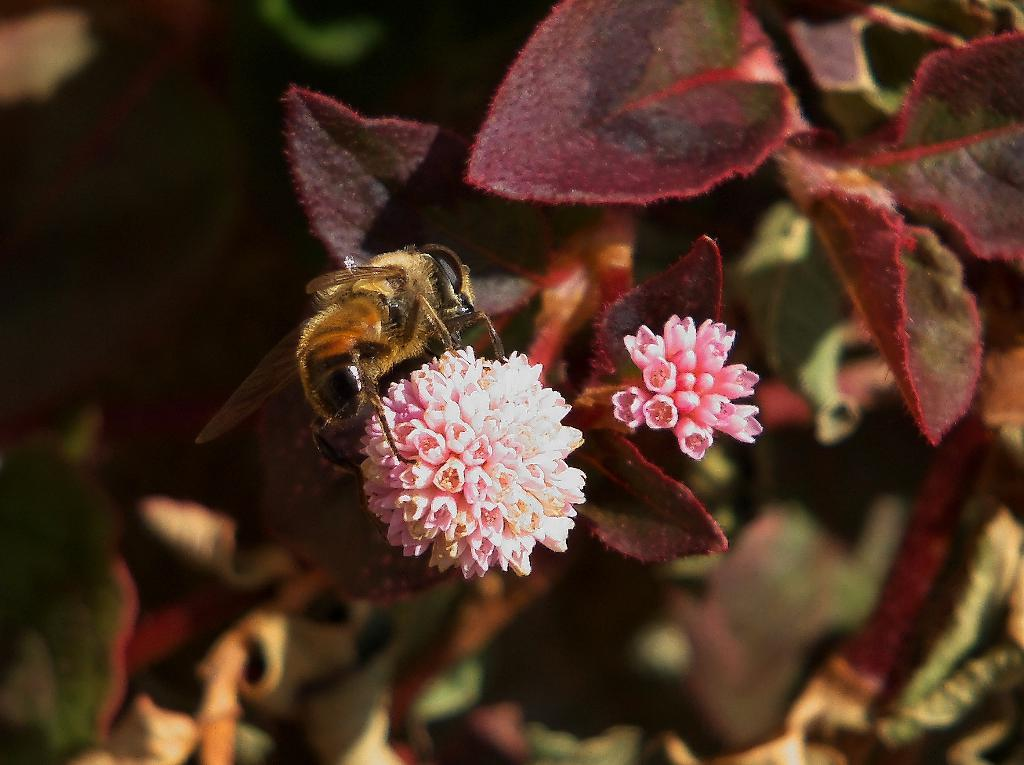What type of living organism can be seen in the image? There is an insect in the image. What type of plants are present in the image? There are flowers and leaves in the image. Can you describe the background of the image? The background of the image is blurry. What is the price of the copper tree in the image? There is no copper tree or any mention of price in the image. 